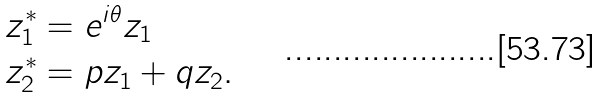<formula> <loc_0><loc_0><loc_500><loc_500>z _ { 1 } ^ { * } & = e ^ { i \theta } z _ { 1 } \\ z _ { 2 } ^ { * } & = p z _ { 1 } + q z _ { 2 } .</formula> 